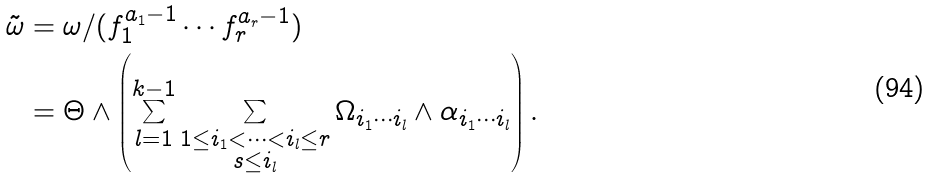<formula> <loc_0><loc_0><loc_500><loc_500>\tilde { \omega } & = \omega / ( f _ { 1 } ^ { a _ { 1 } - 1 } \cdots f _ { r } ^ { a _ { r } - 1 } ) \\ & = \Theta \wedge \left ( \sum _ { l = 1 } ^ { k - 1 } \sum _ { \substack { 1 \leq i _ { 1 } < \cdots < i _ { l } \leq r \\ s \leq i _ { l } } } \Omega _ { i _ { 1 } \cdots i _ { l } } \wedge \alpha _ { i _ { 1 } \cdots i _ { l } } \right ) .</formula> 